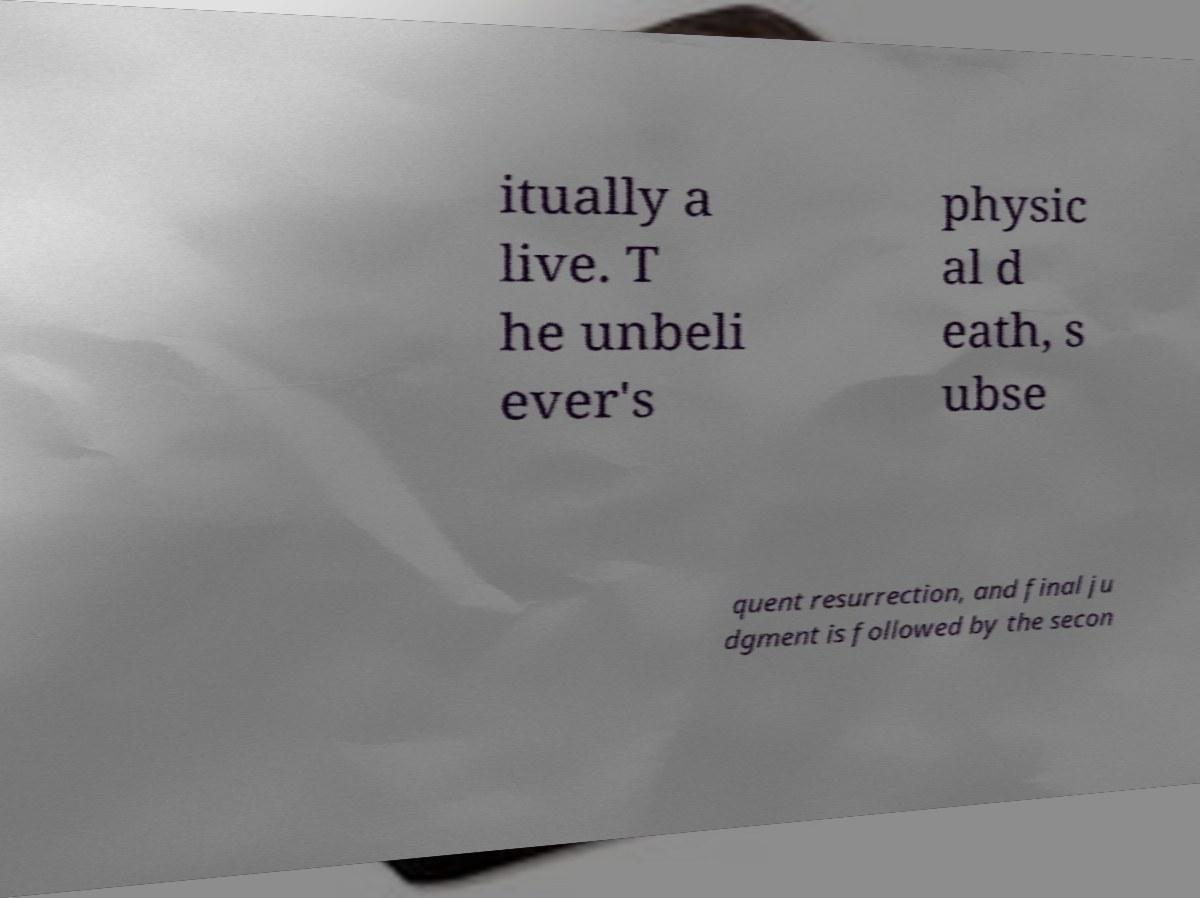Can you accurately transcribe the text from the provided image for me? itually a live. T he unbeli ever's physic al d eath, s ubse quent resurrection, and final ju dgment is followed by the secon 